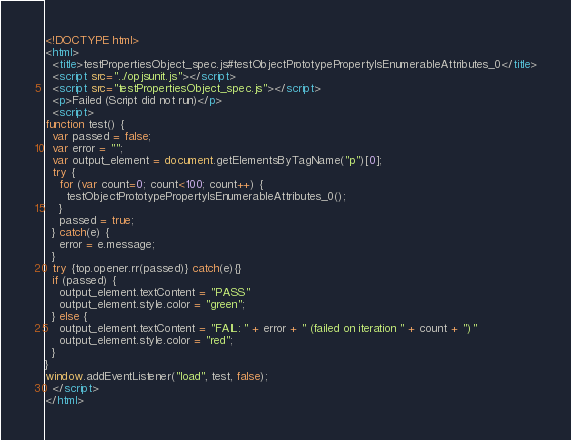Convert code to text. <code><loc_0><loc_0><loc_500><loc_500><_HTML_><!DOCTYPE html>
<html>
  <title>testPropertiesObject_spec.js#testObjectPrototypePropertyIsEnumerableAttributes_0</title>
  <script src="../opjsunit.js"></script>
  <script src="testPropertiesObject_spec.js"></script>
  <p>Failed (Script did not run)</p>
  <script>
function test() {
  var passed = false;
  var error = "";
  var output_element = document.getElementsByTagName("p")[0];
  try {
    for (var count=0; count<100; count++) {
      testObjectPrototypePropertyIsEnumerableAttributes_0();
    }
    passed = true;
  } catch(e) {
    error = e.message;
  }
  try {top.opener.rr(passed)} catch(e){}
  if (passed) {
    output_element.textContent = "PASS"
    output_element.style.color = "green";
  } else {
    output_element.textContent = "FAIL: " + error + " (failed on iteration " + count + ")"
    output_element.style.color = "red";
  }
}
window.addEventListener("load", test, false);
  </script>
</html></code> 